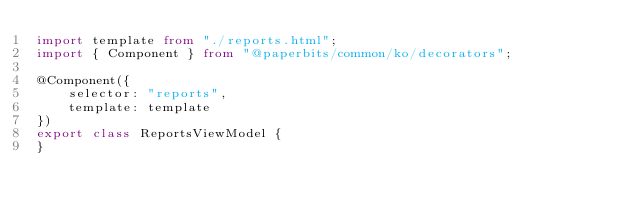Convert code to text. <code><loc_0><loc_0><loc_500><loc_500><_TypeScript_>import template from "./reports.html";
import { Component } from "@paperbits/common/ko/decorators";

@Component({
    selector: "reports",
    template: template
})
export class ReportsViewModel {
}</code> 